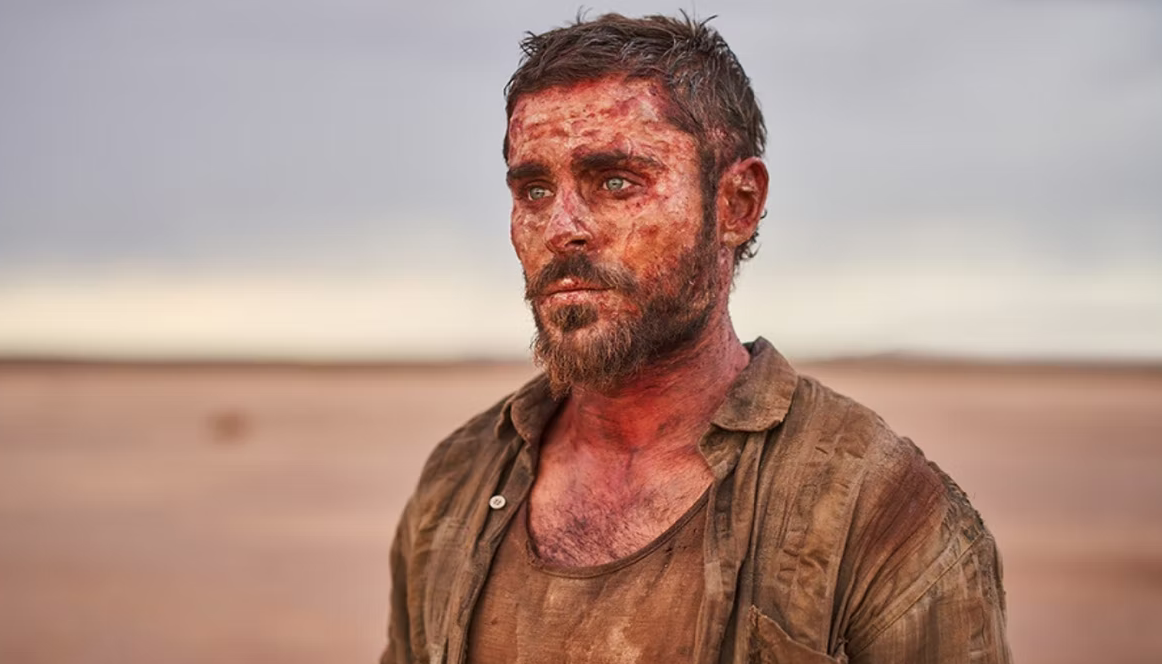What immediate action should the character in the image take to improve his situation? To improve his situation, the character should immediately seek shelter from the harsh desert sun to prevent further dehydration and sunburn. He should assess and tend to his injuries using any available resources and then search for signs of water or a way to signal for help. Conserving physical energy while methodically planning the next steps is crucial to increasing his chances of survival. 